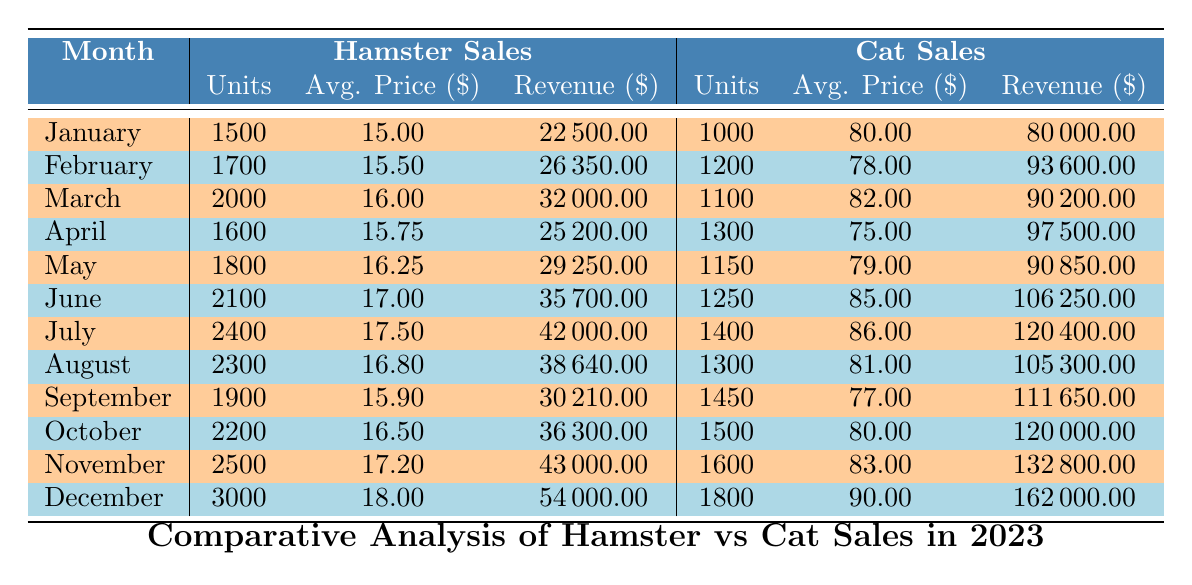What is the total revenue from hamster sales in December? The table shows that in December, the total revenue from hamster sales is listed as $54,000.
Answer: $54,000 How many units of cats were sold in July? From the table, the units sold for cats in July is listed as 1,400.
Answer: 1,400 What was the average price per unit for hamsters in November? According to the table, the average price per unit for hamsters in November is $17.20.
Answer: $17.20 What was the total revenue difference between hamster sales and cat sales in August? For August, hamster sales revenue is $38,640 and cat sales revenue is $105,300. The difference is calculated as $105,300 - $38,640 = $66,660.
Answer: $66,660 Did hamster sales exceed cat sales in any month? By comparing the total revenues for each month, hamster sales did not exceed cat sales in any month throughout the year.
Answer: No What is the total number of units sold for hamsters from January to March? From the table, the units sold for hamsters are: January (1,500), February (1,700), and March (2,000). Adding these gives a total of 1,500 + 1,700 + 2,000 = 5,200 units.
Answer: 5,200 Which month had the highest average price per unit for cats, and what was that price? Upon checking the table, the highest average price per unit for cats occurred in December, which was $90.00.
Answer: $90.00 Calculate the average units sold for hamsters over the entire year. To find the average, sum the units sold for each month (from the data): 1,500 + 1,700 + 2,000 + 1,600 + 1,800 + 2,100 + 2,400 + 2,300 + 1,900 + 2,200 + 2,500 + 3,000 = 25,200. Next, divide this total by 12 (the number of months), yielding 25,200 / 12 = 2,100 units.
Answer: 2,100 What was the total revenue from cat sales for the entire year? Summing the total revenue for each month of cat sales from January to December provides the total: $80,000 + $93,600 + $90,200 + $97,500 + $90,850 + $106,250 + $120,400 + $105,300 + $111,650 + $120,000 + $132,800 + $162,000 = $1,162,550.
Answer: $1,162,550 